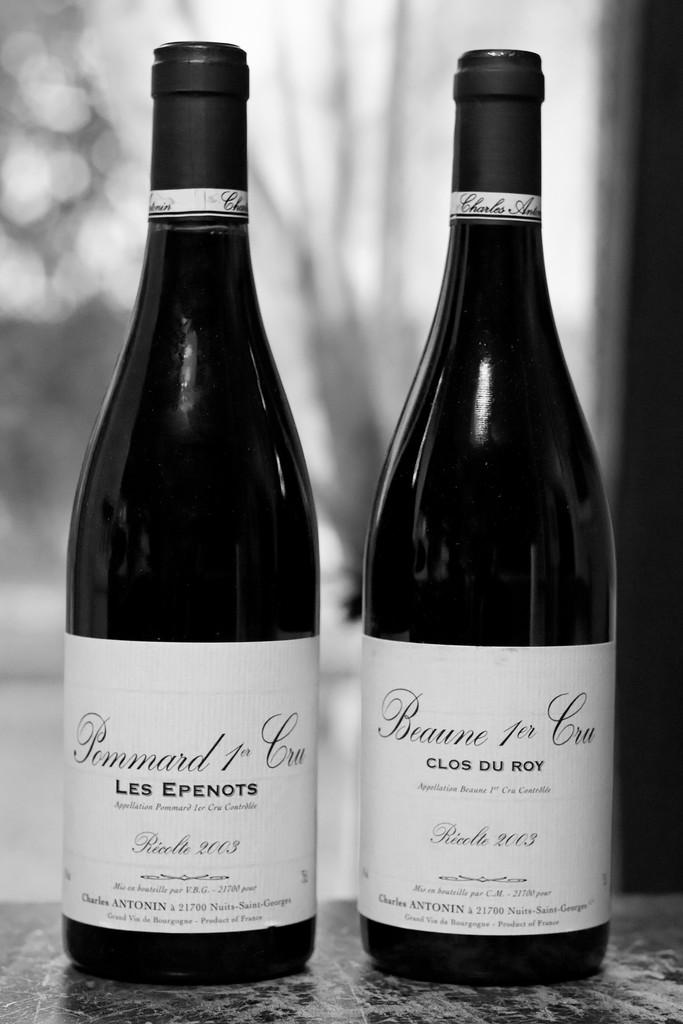<image>
Write a terse but informative summary of the picture. Two unopened bottles of les epenots and clog du roy on a table. 